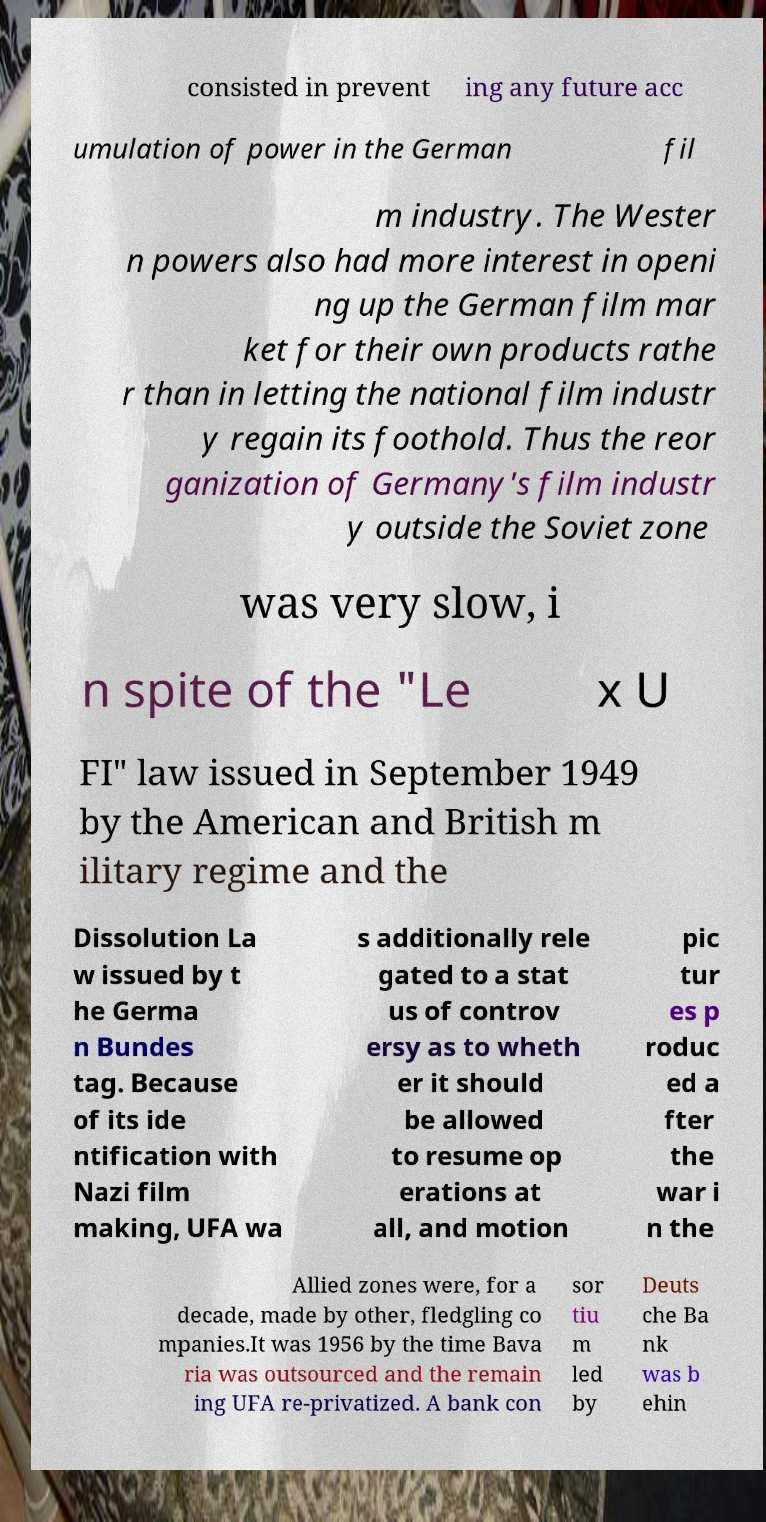Can you accurately transcribe the text from the provided image for me? consisted in prevent ing any future acc umulation of power in the German fil m industry. The Wester n powers also had more interest in openi ng up the German film mar ket for their own products rathe r than in letting the national film industr y regain its foothold. Thus the reor ganization of Germany's film industr y outside the Soviet zone was very slow, i n spite of the "Le x U FI" law issued in September 1949 by the American and British m ilitary regime and the Dissolution La w issued by t he Germa n Bundes tag. Because of its ide ntification with Nazi film making, UFA wa s additionally rele gated to a stat us of controv ersy as to wheth er it should be allowed to resume op erations at all, and motion pic tur es p roduc ed a fter the war i n the Allied zones were, for a decade, made by other, fledgling co mpanies.It was 1956 by the time Bava ria was outsourced and the remain ing UFA re-privatized. A bank con sor tiu m led by Deuts che Ba nk was b ehin 